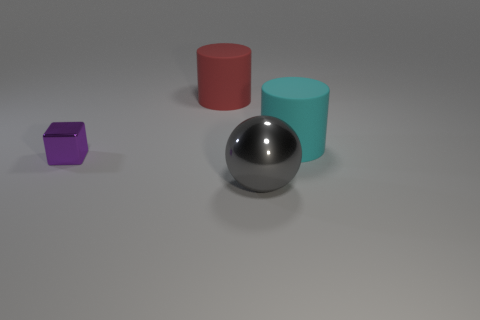The rubber thing to the right of the gray object is what color?
Your answer should be very brief. Cyan. How many shiny objects are either big cyan cylinders or gray objects?
Your answer should be compact. 1. How many gray things are the same size as the purple block?
Your response must be concise. 0. There is a thing that is to the left of the big shiny thing and on the right side of the purple thing; what color is it?
Make the answer very short. Red. What number of objects are large yellow matte cylinders or tiny purple blocks?
Make the answer very short. 1. What number of tiny things are either metal balls or purple balls?
Offer a very short reply. 0. Is there any other thing of the same color as the ball?
Give a very brief answer. No. What is the size of the object that is both in front of the cyan matte cylinder and behind the large ball?
Your response must be concise. Small. There is a cylinder that is to the right of the red matte cylinder; is its color the same as the big matte object on the left side of the large ball?
Offer a terse response. No. How many other things are the same material as the ball?
Your answer should be compact. 1. 